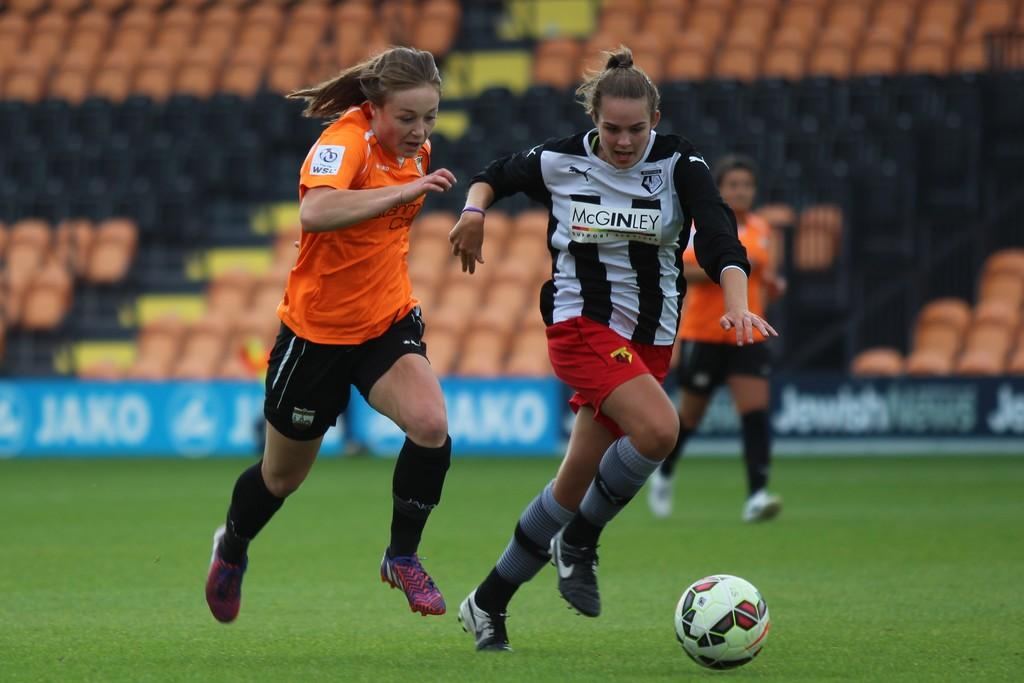<image>
Render a clear and concise summary of the photo. A girl wears a jersey that reads McGinley while kicking a ball. 